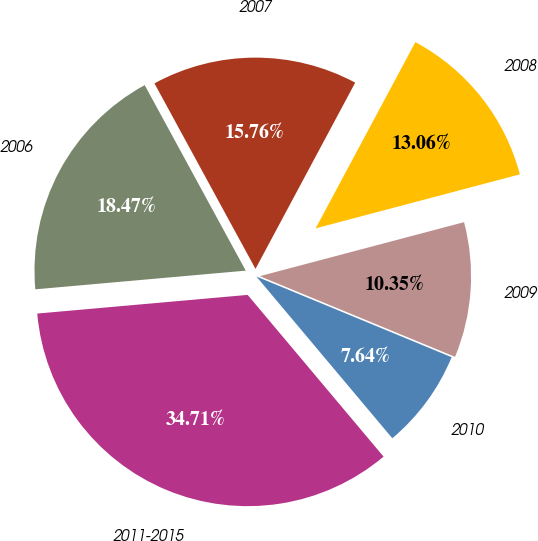Convert chart to OTSL. <chart><loc_0><loc_0><loc_500><loc_500><pie_chart><fcel>2006<fcel>2007<fcel>2008<fcel>2009<fcel>2010<fcel>2011-2015<nl><fcel>18.47%<fcel>15.76%<fcel>13.06%<fcel>10.35%<fcel>7.64%<fcel>34.71%<nl></chart> 